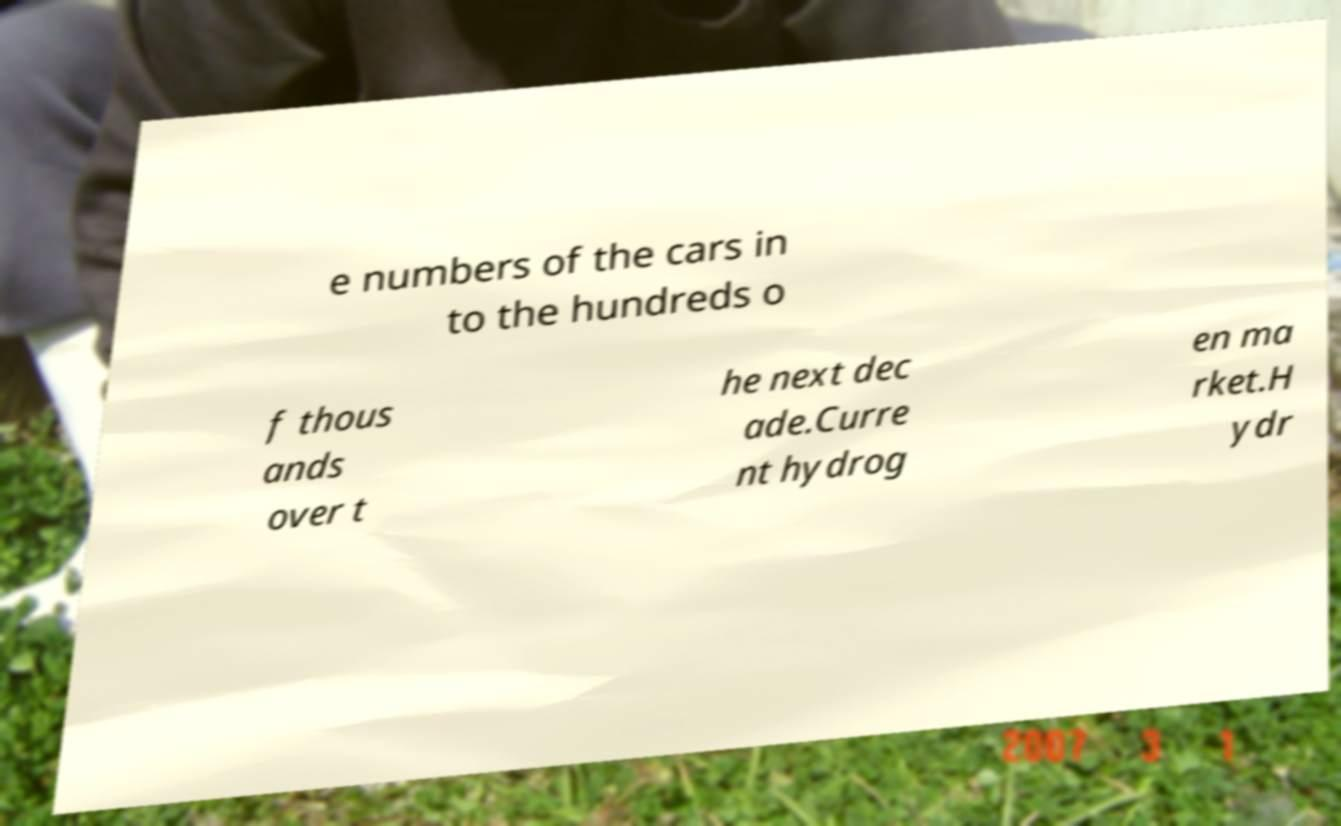Could you assist in decoding the text presented in this image and type it out clearly? e numbers of the cars in to the hundreds o f thous ands over t he next dec ade.Curre nt hydrog en ma rket.H ydr 